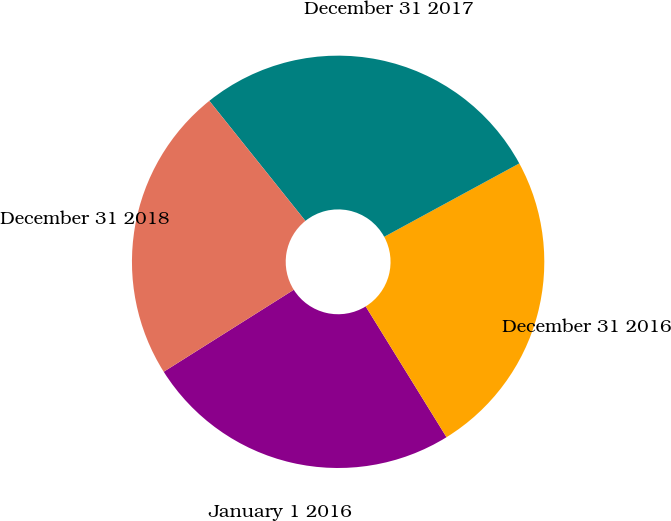<chart> <loc_0><loc_0><loc_500><loc_500><pie_chart><fcel>January 1 2016<fcel>December 31 2016<fcel>December 31 2017<fcel>December 31 2018<nl><fcel>24.86%<fcel>24.11%<fcel>27.82%<fcel>23.21%<nl></chart> 